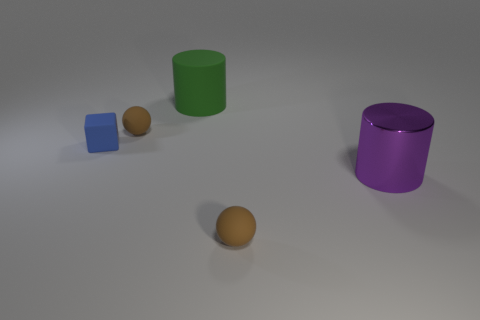Does the purple object have the same shape as the small blue matte object?
Make the answer very short. No. What number of other things are there of the same size as the matte block?
Make the answer very short. 2. What number of things are brown matte balls that are behind the tiny blue cube or tiny rubber things behind the small blue object?
Your answer should be compact. 1. How many other objects are the same shape as the big green thing?
Keep it short and to the point. 1. What is the material of the object that is behind the small block and left of the green rubber cylinder?
Give a very brief answer. Rubber. There is a matte cylinder; what number of blue rubber things are right of it?
Provide a short and direct response. 0. What number of green matte balls are there?
Your answer should be compact. 0. Is the size of the metal thing the same as the blue cube?
Provide a succinct answer. No. Are there any big green rubber things in front of the small brown thing right of the cylinder that is behind the small matte cube?
Provide a short and direct response. No. There is another object that is the same shape as the green rubber object; what is its material?
Offer a very short reply. Metal. 